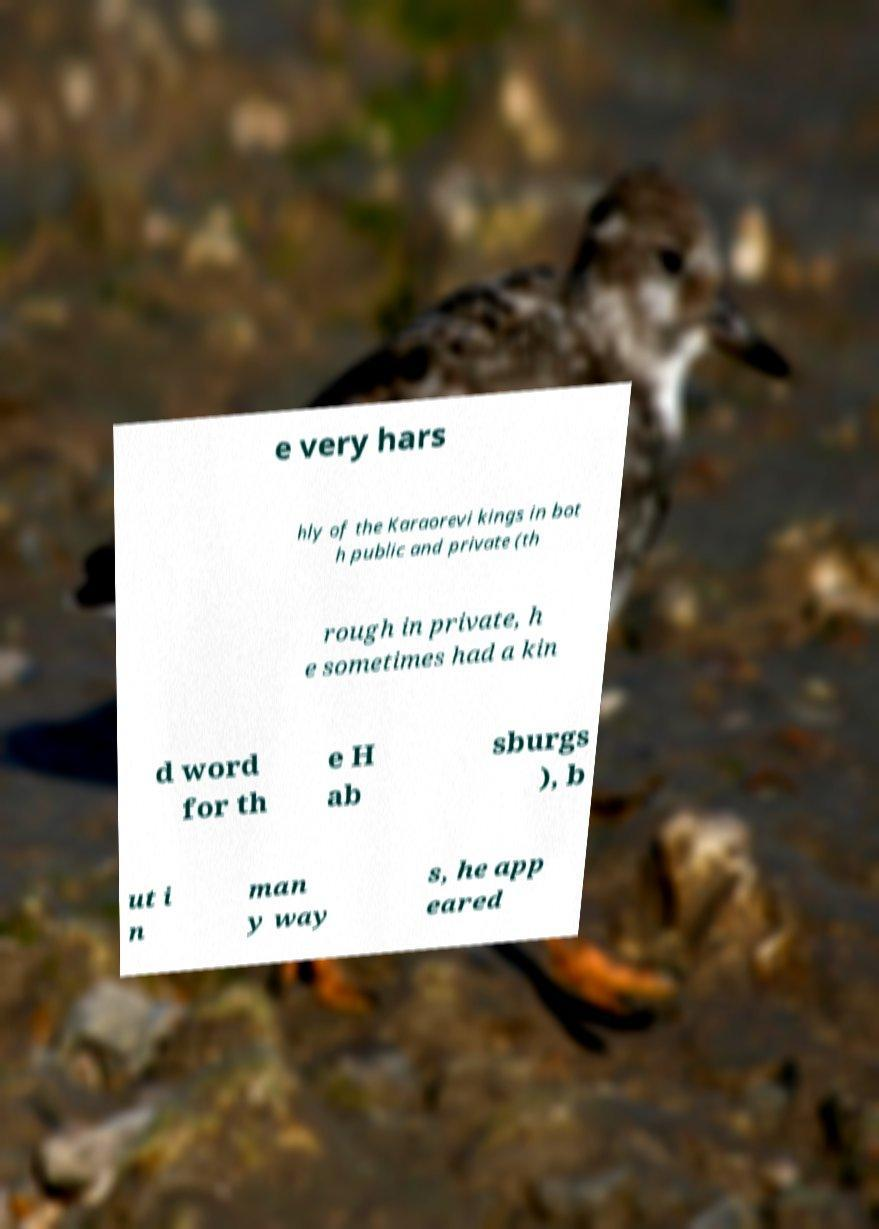What messages or text are displayed in this image? I need them in a readable, typed format. e very hars hly of the Karaorevi kings in bot h public and private (th rough in private, h e sometimes had a kin d word for th e H ab sburgs ), b ut i n man y way s, he app eared 